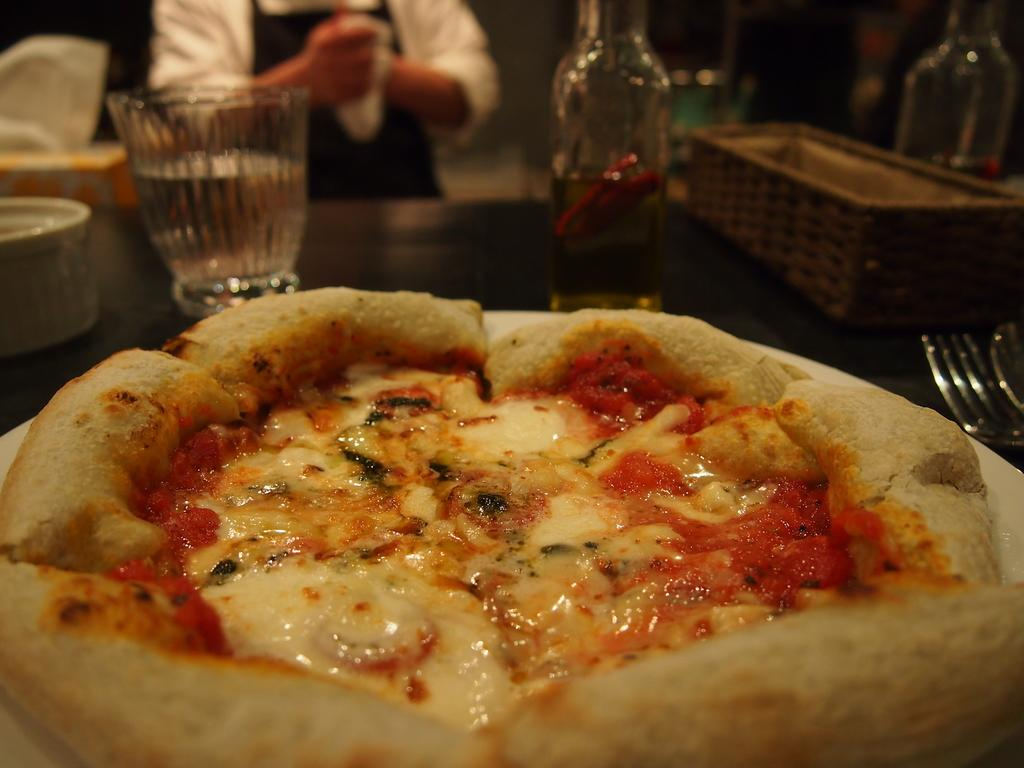What is the main piece of furniture in the image? There is a table in the image. What food item is on the table? There is a pizza on the table. What type of dishware is around the pizza? There are glasses around the pizza. What utensil is on the table? There is a fork on the table. What else is on the table besides the pizza and utensils? There is a box on the table. Can you hear the thunder in the image? There is no mention of thunder or any sound in the image, so it cannot be heard. 